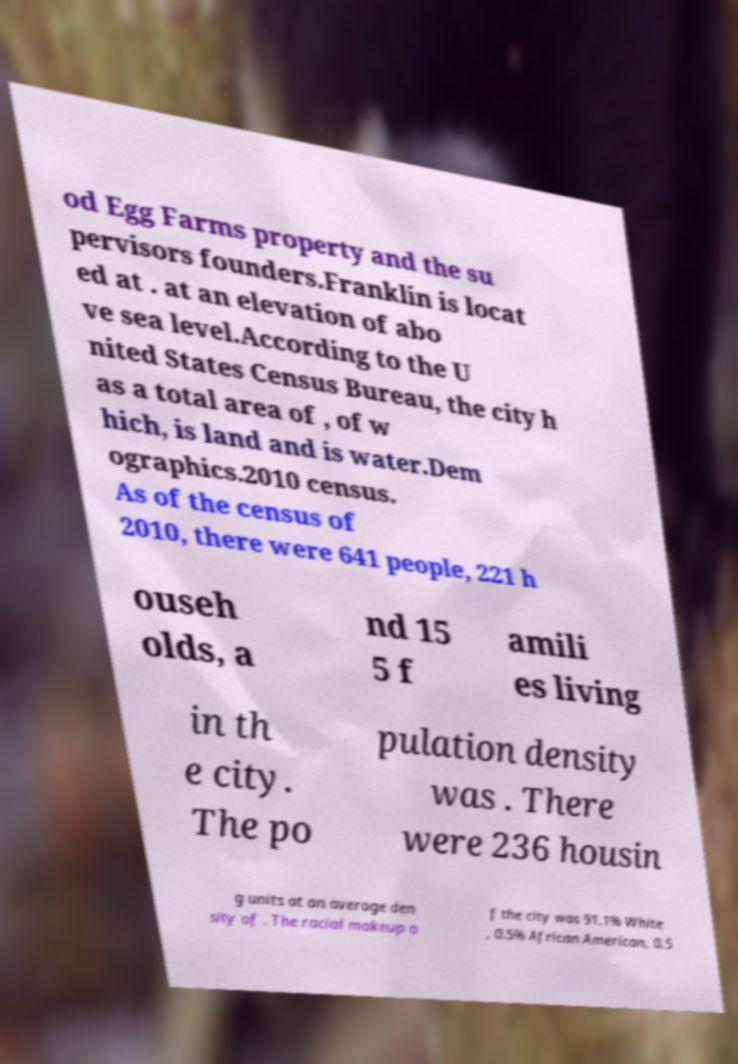Can you accurately transcribe the text from the provided image for me? od Egg Farms property and the su pervisors founders.Franklin is locat ed at . at an elevation of abo ve sea level.According to the U nited States Census Bureau, the city h as a total area of , of w hich, is land and is water.Dem ographics.2010 census. As of the census of 2010, there were 641 people, 221 h ouseh olds, a nd 15 5 f amili es living in th e city. The po pulation density was . There were 236 housin g units at an average den sity of . The racial makeup o f the city was 91.1% White , 0.5% African American, 0.5 